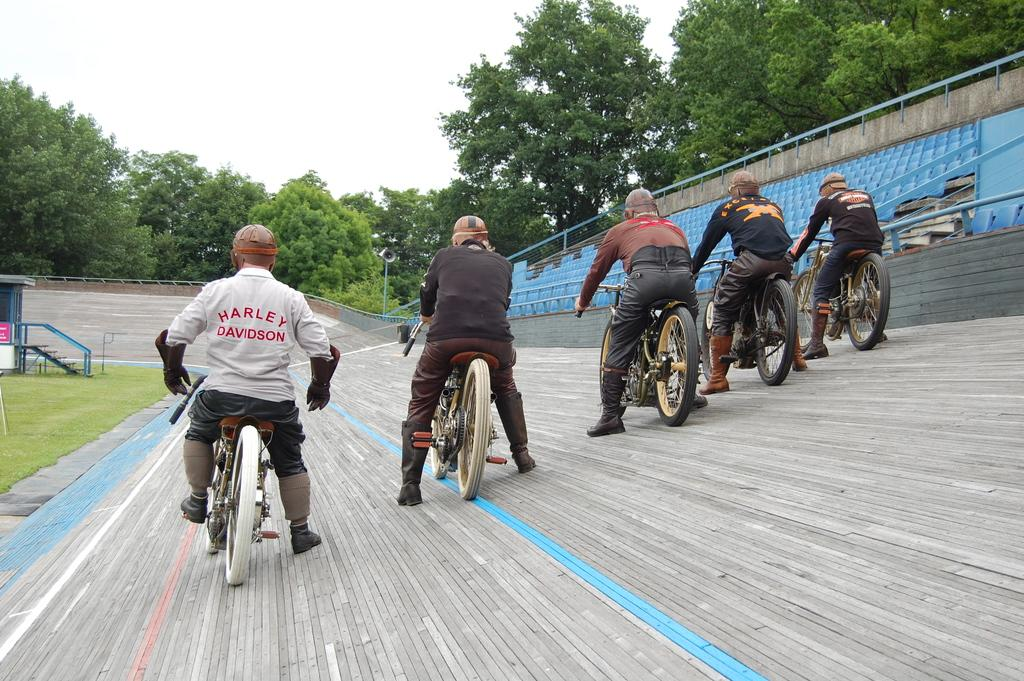What are the people in the image doing? The group of persons is riding bicycles on a wall. What can be seen in the background of the image? In the background, there are chairs, iron rods, a staircase, grass, a small house, trees, and the sky. Can you describe the setting where the people are riding bicycles? The people are riding bicycles on a wall in a background that includes various elements such as chairs, iron rods, a staircase, grass, a small house, trees, and the sky. What type of meal is being prepared by the pigs in the image? There are no pigs or any indication of a meal being prepared in the image. How many dogs are visible in the image? There are no dogs present in the image. 